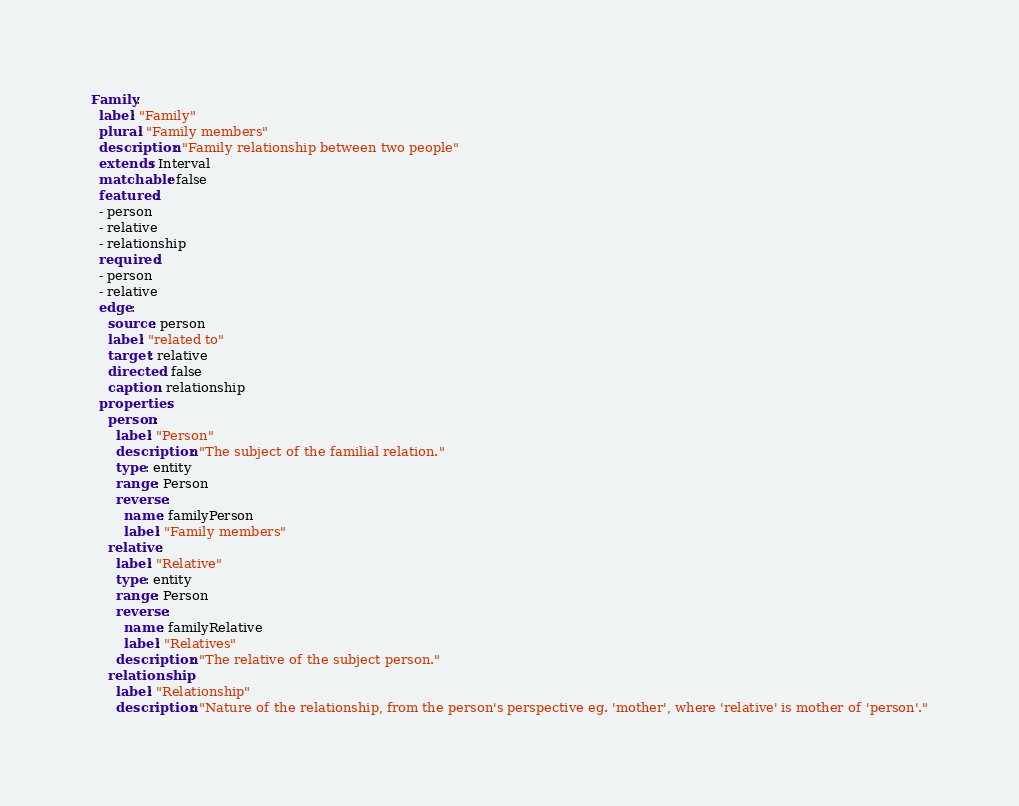Convert code to text. <code><loc_0><loc_0><loc_500><loc_500><_YAML_>Family:
  label: "Family"
  plural: "Family members"
  description: "Family relationship between two people"
  extends: Interval
  matchable: false
  featured:
  - person
  - relative
  - relationship
  required:
  - person
  - relative
  edge:
    source: person
    label: "related to"
    target: relative
    directed: false
    caption: relationship
  properties:
    person:
      label: "Person"
      description: "The subject of the familial relation."
      type: entity
      range: Person
      reverse:
        name: familyPerson
        label: "Family members"
    relative:
      label: "Relative"
      type: entity
      range: Person
      reverse:
        name: familyRelative
        label: "Relatives"
      description: "The relative of the subject person."
    relationship:
      label: "Relationship"
      description: "Nature of the relationship, from the person's perspective eg. 'mother', where 'relative' is mother of 'person'."</code> 